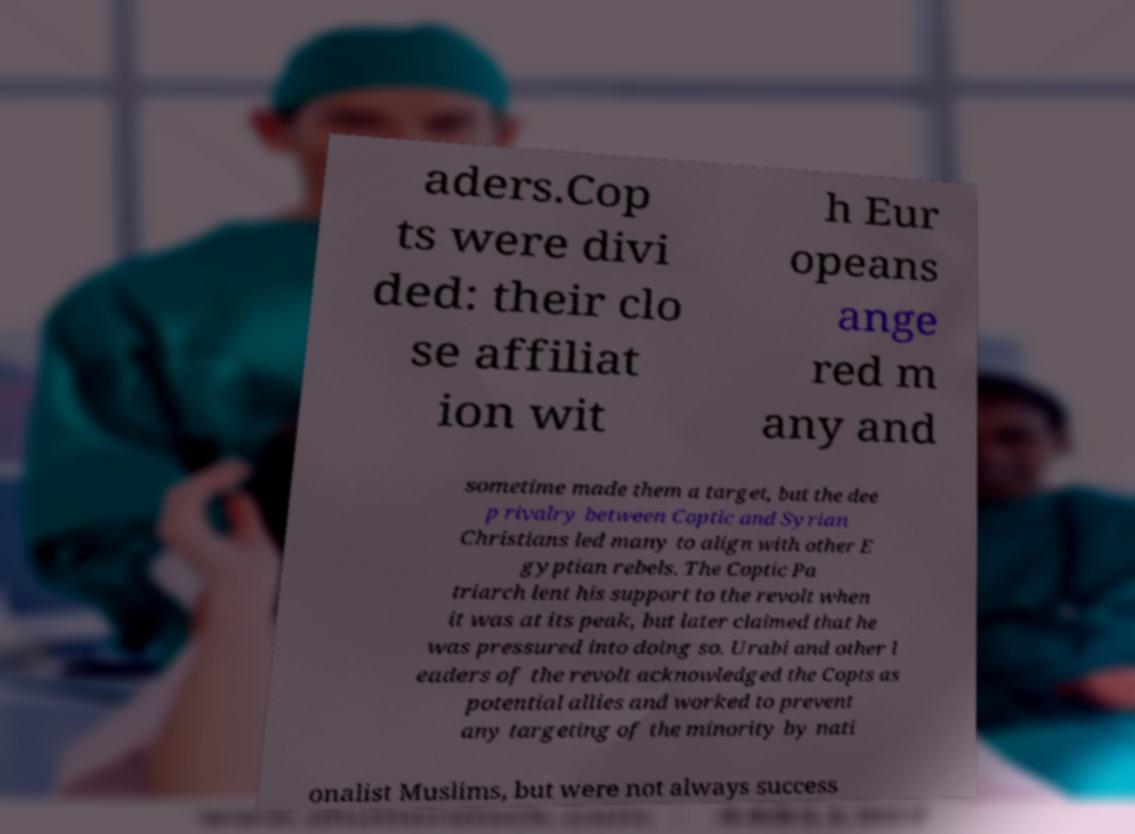Could you assist in decoding the text presented in this image and type it out clearly? aders.Cop ts were divi ded: their clo se affiliat ion wit h Eur opeans ange red m any and sometime made them a target, but the dee p rivalry between Coptic and Syrian Christians led many to align with other E gyptian rebels. The Coptic Pa triarch lent his support to the revolt when it was at its peak, but later claimed that he was pressured into doing so. Urabi and other l eaders of the revolt acknowledged the Copts as potential allies and worked to prevent any targeting of the minority by nati onalist Muslims, but were not always success 